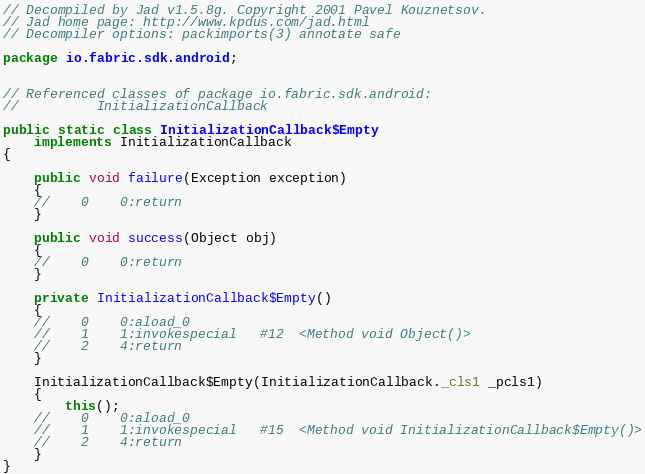<code> <loc_0><loc_0><loc_500><loc_500><_Java_>// Decompiled by Jad v1.5.8g. Copyright 2001 Pavel Kouznetsov.
// Jad home page: http://www.kpdus.com/jad.html
// Decompiler options: packimports(3) annotate safe 

package io.fabric.sdk.android;


// Referenced classes of package io.fabric.sdk.android:
//			InitializationCallback

public static class InitializationCallback$Empty
	implements InitializationCallback
{

	public void failure(Exception exception)
	{
	//    0    0:return          
	}

	public void success(Object obj)
	{
	//    0    0:return          
	}

	private InitializationCallback$Empty()
	{
	//    0    0:aload_0         
	//    1    1:invokespecial   #12  <Method void Object()>
	//    2    4:return          
	}

	InitializationCallback$Empty(InitializationCallback._cls1 _pcls1)
	{
		this();
	//    0    0:aload_0         
	//    1    1:invokespecial   #15  <Method void InitializationCallback$Empty()>
	//    2    4:return          
	}
}
</code> 